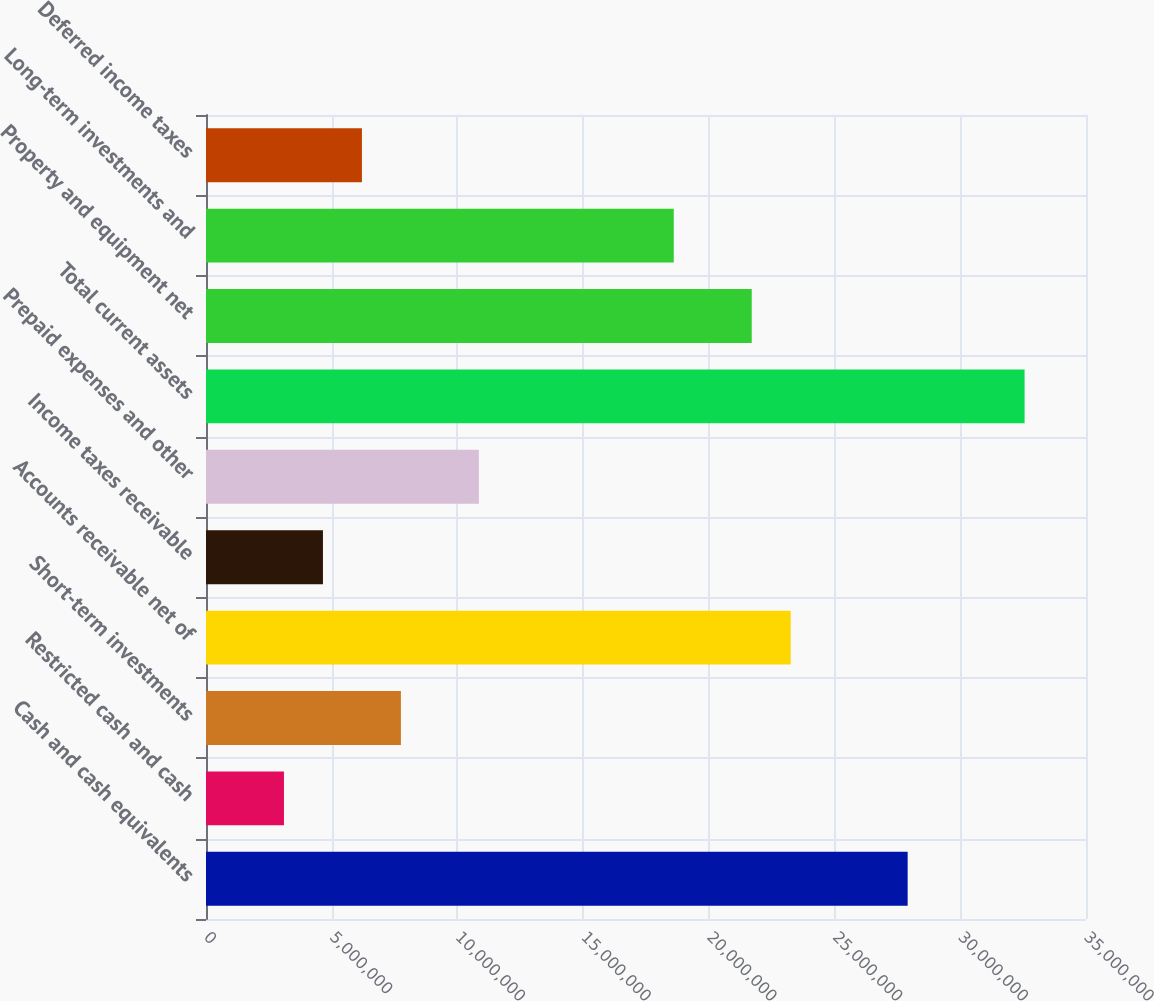Convert chart. <chart><loc_0><loc_0><loc_500><loc_500><bar_chart><fcel>Cash and cash equivalents<fcel>Restricted cash and cash<fcel>Short-term investments<fcel>Accounts receivable net of<fcel>Income taxes receivable<fcel>Prepaid expenses and other<fcel>Total current assets<fcel>Property and equipment net<fcel>Long-term investments and<fcel>Deferred income taxes<nl><fcel>2.79069e+07<fcel>3.10076e+06<fcel>7.75191e+06<fcel>2.32557e+07<fcel>4.65114e+06<fcel>1.08527e+07<fcel>3.2558e+07<fcel>2.17053e+07<fcel>1.86046e+07<fcel>6.20153e+06<nl></chart> 